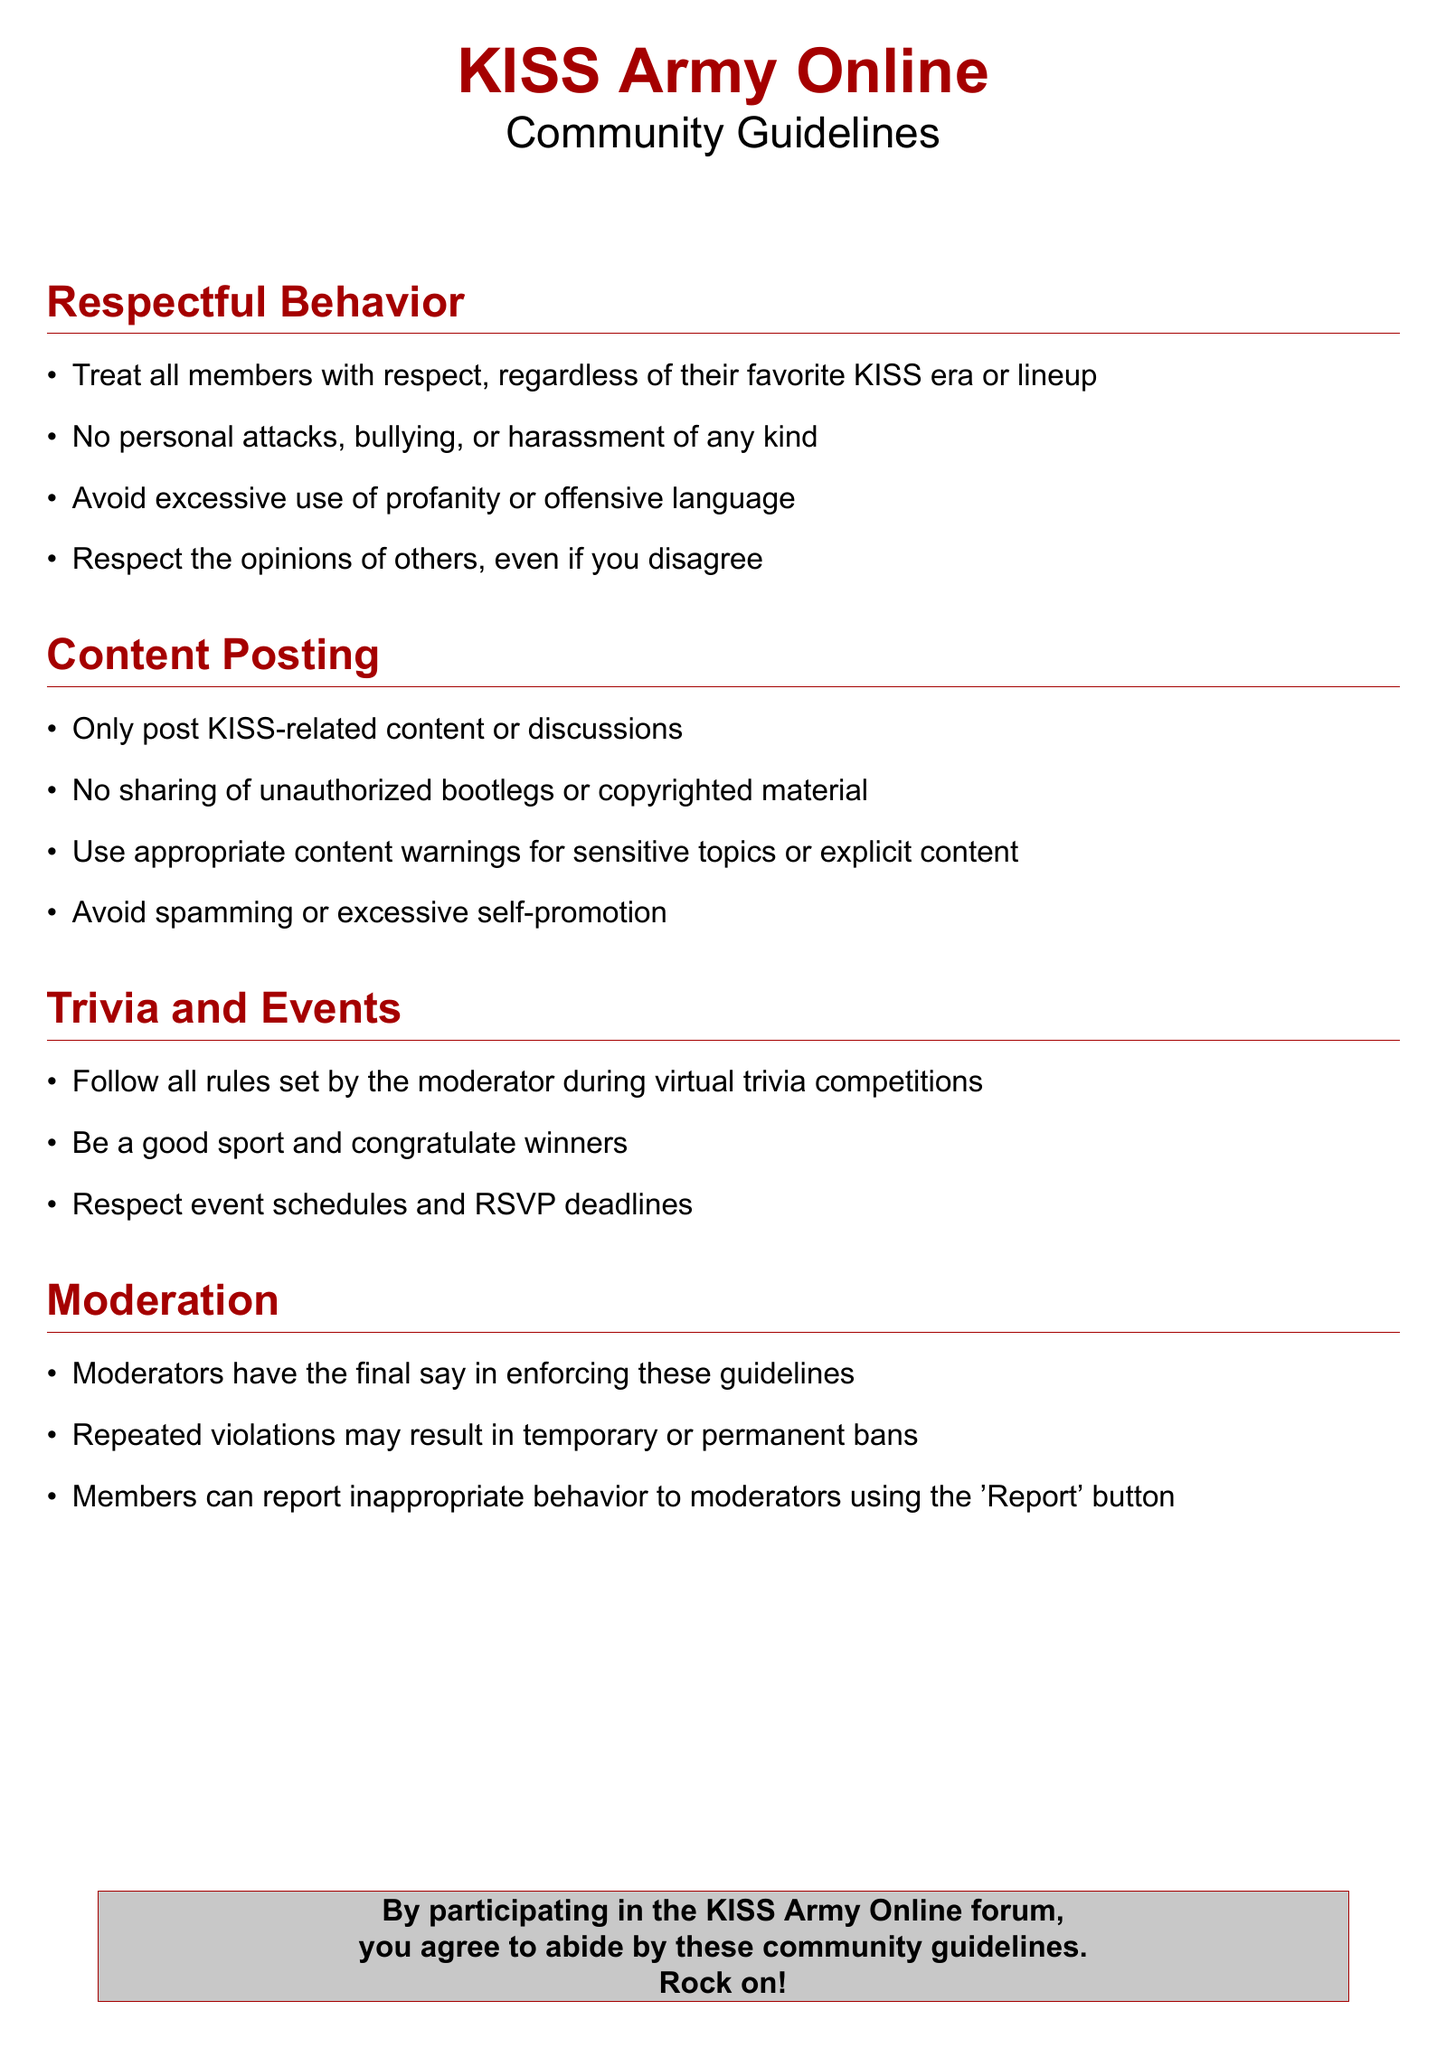What is the main theme of the document? The main theme is to outline guidelines for community behavior and content posting on the KISS fan forum.
Answer: Community Guidelines What type of content is allowed for posting? The document specifies that only KISS-related content or discussions are allowed.
Answer: KISS-related content What should members do if they witness inappropriate behavior? Members are advised to report inappropriate behavior to moderators using the 'Report' button.
Answer: Report What is the consequence for repeated violations of the guidelines? The document states that repeated violations may result in temporary or permanent bans.
Answer: Temporary or permanent bans What is required of members during virtual trivia competitions? Members are required to follow all rules set by the moderator during virtual trivia competitions.
Answer: Follow rules How should members treat each other's opinions? The guidelines suggest that members should respect the opinions of others, even if they disagree.
Answer: Respect opinions What should be used for sensitive topics or explicit content? Appropriate content warnings should be used for sensitive topics or explicit content.
Answer: Content warnings What is the designated color for section titles in the document? The color designated for section titles is kissDarkRed.
Answer: kissDarkRed 